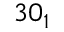<formula> <loc_0><loc_0><loc_500><loc_500>3 0 _ { 1 }</formula> 